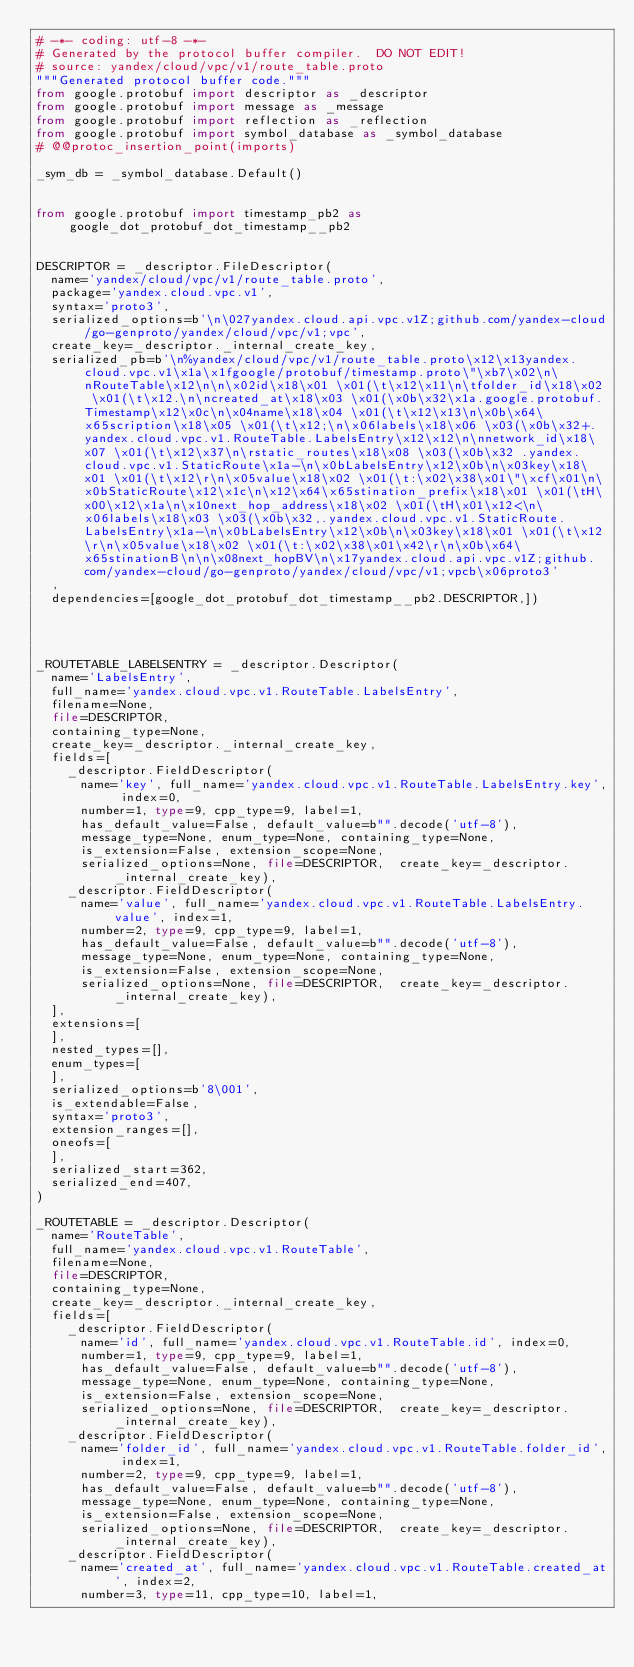Convert code to text. <code><loc_0><loc_0><loc_500><loc_500><_Python_># -*- coding: utf-8 -*-
# Generated by the protocol buffer compiler.  DO NOT EDIT!
# source: yandex/cloud/vpc/v1/route_table.proto
"""Generated protocol buffer code."""
from google.protobuf import descriptor as _descriptor
from google.protobuf import message as _message
from google.protobuf import reflection as _reflection
from google.protobuf import symbol_database as _symbol_database
# @@protoc_insertion_point(imports)

_sym_db = _symbol_database.Default()


from google.protobuf import timestamp_pb2 as google_dot_protobuf_dot_timestamp__pb2


DESCRIPTOR = _descriptor.FileDescriptor(
  name='yandex/cloud/vpc/v1/route_table.proto',
  package='yandex.cloud.vpc.v1',
  syntax='proto3',
  serialized_options=b'\n\027yandex.cloud.api.vpc.v1Z;github.com/yandex-cloud/go-genproto/yandex/cloud/vpc/v1;vpc',
  create_key=_descriptor._internal_create_key,
  serialized_pb=b'\n%yandex/cloud/vpc/v1/route_table.proto\x12\x13yandex.cloud.vpc.v1\x1a\x1fgoogle/protobuf/timestamp.proto\"\xb7\x02\n\nRouteTable\x12\n\n\x02id\x18\x01 \x01(\t\x12\x11\n\tfolder_id\x18\x02 \x01(\t\x12.\n\ncreated_at\x18\x03 \x01(\x0b\x32\x1a.google.protobuf.Timestamp\x12\x0c\n\x04name\x18\x04 \x01(\t\x12\x13\n\x0b\x64\x65scription\x18\x05 \x01(\t\x12;\n\x06labels\x18\x06 \x03(\x0b\x32+.yandex.cloud.vpc.v1.RouteTable.LabelsEntry\x12\x12\n\nnetwork_id\x18\x07 \x01(\t\x12\x37\n\rstatic_routes\x18\x08 \x03(\x0b\x32 .yandex.cloud.vpc.v1.StaticRoute\x1a-\n\x0bLabelsEntry\x12\x0b\n\x03key\x18\x01 \x01(\t\x12\r\n\x05value\x18\x02 \x01(\t:\x02\x38\x01\"\xcf\x01\n\x0bStaticRoute\x12\x1c\n\x12\x64\x65stination_prefix\x18\x01 \x01(\tH\x00\x12\x1a\n\x10next_hop_address\x18\x02 \x01(\tH\x01\x12<\n\x06labels\x18\x03 \x03(\x0b\x32,.yandex.cloud.vpc.v1.StaticRoute.LabelsEntry\x1a-\n\x0bLabelsEntry\x12\x0b\n\x03key\x18\x01 \x01(\t\x12\r\n\x05value\x18\x02 \x01(\t:\x02\x38\x01\x42\r\n\x0b\x64\x65stinationB\n\n\x08next_hopBV\n\x17yandex.cloud.api.vpc.v1Z;github.com/yandex-cloud/go-genproto/yandex/cloud/vpc/v1;vpcb\x06proto3'
  ,
  dependencies=[google_dot_protobuf_dot_timestamp__pb2.DESCRIPTOR,])




_ROUTETABLE_LABELSENTRY = _descriptor.Descriptor(
  name='LabelsEntry',
  full_name='yandex.cloud.vpc.v1.RouteTable.LabelsEntry',
  filename=None,
  file=DESCRIPTOR,
  containing_type=None,
  create_key=_descriptor._internal_create_key,
  fields=[
    _descriptor.FieldDescriptor(
      name='key', full_name='yandex.cloud.vpc.v1.RouteTable.LabelsEntry.key', index=0,
      number=1, type=9, cpp_type=9, label=1,
      has_default_value=False, default_value=b"".decode('utf-8'),
      message_type=None, enum_type=None, containing_type=None,
      is_extension=False, extension_scope=None,
      serialized_options=None, file=DESCRIPTOR,  create_key=_descriptor._internal_create_key),
    _descriptor.FieldDescriptor(
      name='value', full_name='yandex.cloud.vpc.v1.RouteTable.LabelsEntry.value', index=1,
      number=2, type=9, cpp_type=9, label=1,
      has_default_value=False, default_value=b"".decode('utf-8'),
      message_type=None, enum_type=None, containing_type=None,
      is_extension=False, extension_scope=None,
      serialized_options=None, file=DESCRIPTOR,  create_key=_descriptor._internal_create_key),
  ],
  extensions=[
  ],
  nested_types=[],
  enum_types=[
  ],
  serialized_options=b'8\001',
  is_extendable=False,
  syntax='proto3',
  extension_ranges=[],
  oneofs=[
  ],
  serialized_start=362,
  serialized_end=407,
)

_ROUTETABLE = _descriptor.Descriptor(
  name='RouteTable',
  full_name='yandex.cloud.vpc.v1.RouteTable',
  filename=None,
  file=DESCRIPTOR,
  containing_type=None,
  create_key=_descriptor._internal_create_key,
  fields=[
    _descriptor.FieldDescriptor(
      name='id', full_name='yandex.cloud.vpc.v1.RouteTable.id', index=0,
      number=1, type=9, cpp_type=9, label=1,
      has_default_value=False, default_value=b"".decode('utf-8'),
      message_type=None, enum_type=None, containing_type=None,
      is_extension=False, extension_scope=None,
      serialized_options=None, file=DESCRIPTOR,  create_key=_descriptor._internal_create_key),
    _descriptor.FieldDescriptor(
      name='folder_id', full_name='yandex.cloud.vpc.v1.RouteTable.folder_id', index=1,
      number=2, type=9, cpp_type=9, label=1,
      has_default_value=False, default_value=b"".decode('utf-8'),
      message_type=None, enum_type=None, containing_type=None,
      is_extension=False, extension_scope=None,
      serialized_options=None, file=DESCRIPTOR,  create_key=_descriptor._internal_create_key),
    _descriptor.FieldDescriptor(
      name='created_at', full_name='yandex.cloud.vpc.v1.RouteTable.created_at', index=2,
      number=3, type=11, cpp_type=10, label=1,</code> 